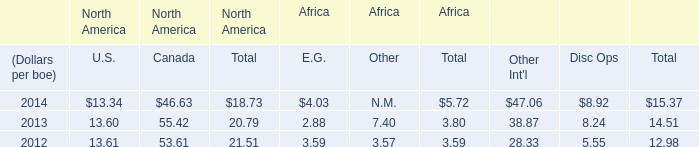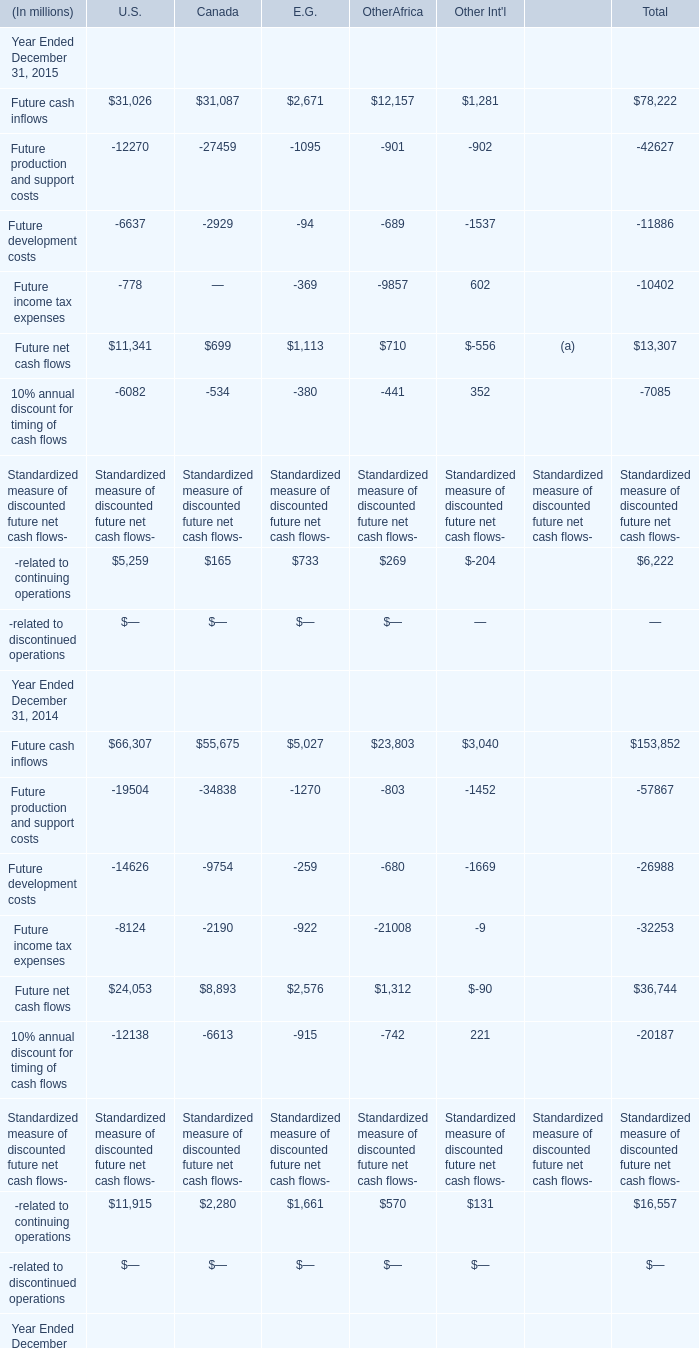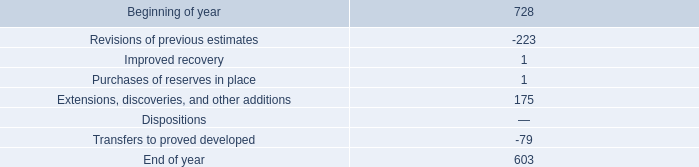What is the sum of the Future production and support costs in the years where Future cash inflows greater than 150000? (in million) 
Computations: (-56514 - 57867)
Answer: -114381.0. 